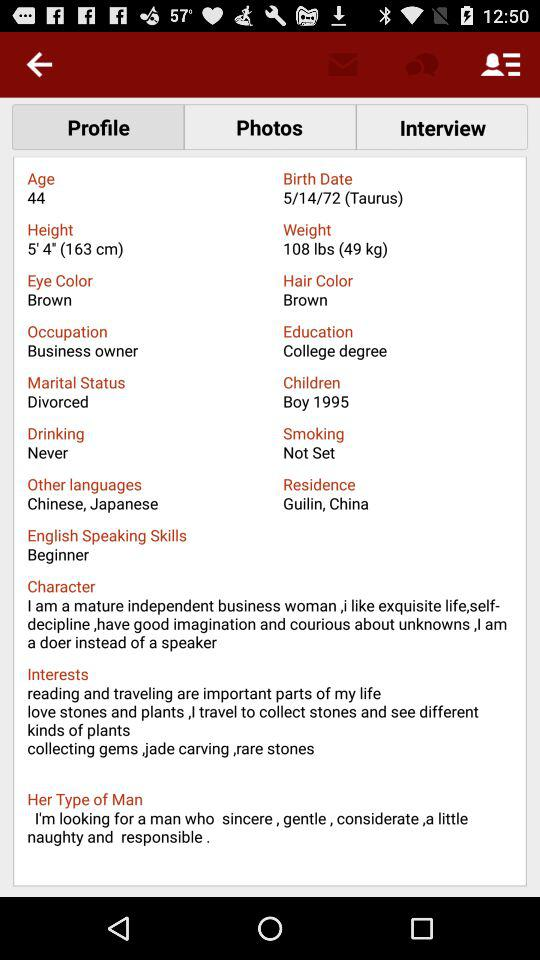What is the person's proficiency level in English-speaking skills? The person's proficiency level in English-speaking skills is beginner. 